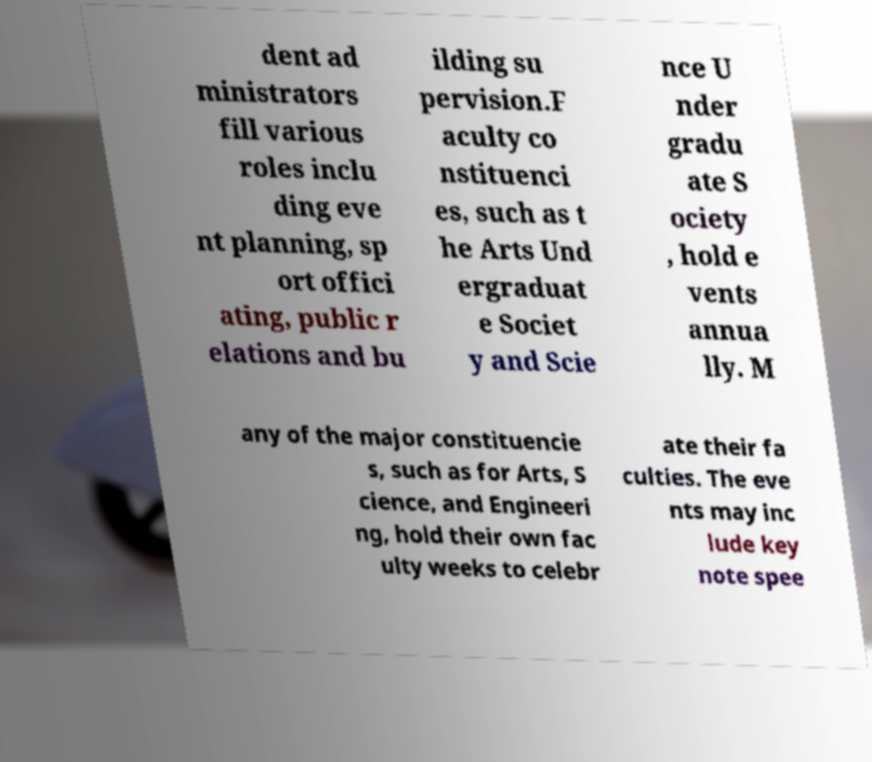Could you assist in decoding the text presented in this image and type it out clearly? dent ad ministrators fill various roles inclu ding eve nt planning, sp ort offici ating, public r elations and bu ilding su pervision.F aculty co nstituenci es, such as t he Arts Und ergraduat e Societ y and Scie nce U nder gradu ate S ociety , hold e vents annua lly. M any of the major constituencie s, such as for Arts, S cience, and Engineeri ng, hold their own fac ulty weeks to celebr ate their fa culties. The eve nts may inc lude key note spee 